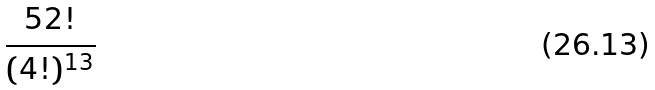<formula> <loc_0><loc_0><loc_500><loc_500>\frac { 5 2 ! } { ( 4 ! ) ^ { 1 3 } }</formula> 